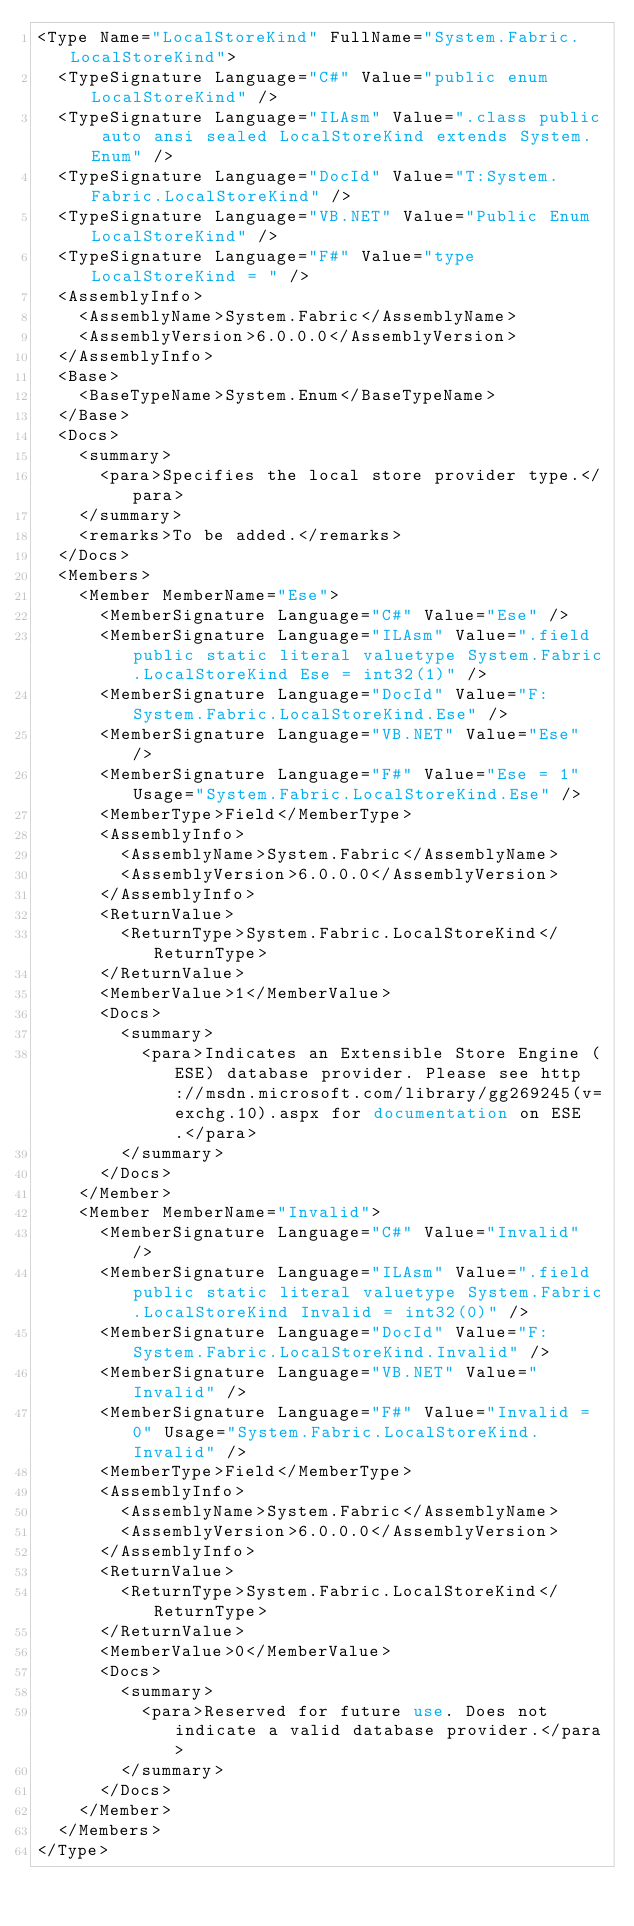Convert code to text. <code><loc_0><loc_0><loc_500><loc_500><_XML_><Type Name="LocalStoreKind" FullName="System.Fabric.LocalStoreKind">
  <TypeSignature Language="C#" Value="public enum LocalStoreKind" />
  <TypeSignature Language="ILAsm" Value=".class public auto ansi sealed LocalStoreKind extends System.Enum" />
  <TypeSignature Language="DocId" Value="T:System.Fabric.LocalStoreKind" />
  <TypeSignature Language="VB.NET" Value="Public Enum LocalStoreKind" />
  <TypeSignature Language="F#" Value="type LocalStoreKind = " />
  <AssemblyInfo>
    <AssemblyName>System.Fabric</AssemblyName>
    <AssemblyVersion>6.0.0.0</AssemblyVersion>
  </AssemblyInfo>
  <Base>
    <BaseTypeName>System.Enum</BaseTypeName>
  </Base>
  <Docs>
    <summary>
      <para>Specifies the local store provider type.</para>
    </summary>
    <remarks>To be added.</remarks>
  </Docs>
  <Members>
    <Member MemberName="Ese">
      <MemberSignature Language="C#" Value="Ese" />
      <MemberSignature Language="ILAsm" Value=".field public static literal valuetype System.Fabric.LocalStoreKind Ese = int32(1)" />
      <MemberSignature Language="DocId" Value="F:System.Fabric.LocalStoreKind.Ese" />
      <MemberSignature Language="VB.NET" Value="Ese" />
      <MemberSignature Language="F#" Value="Ese = 1" Usage="System.Fabric.LocalStoreKind.Ese" />
      <MemberType>Field</MemberType>
      <AssemblyInfo>
        <AssemblyName>System.Fabric</AssemblyName>
        <AssemblyVersion>6.0.0.0</AssemblyVersion>
      </AssemblyInfo>
      <ReturnValue>
        <ReturnType>System.Fabric.LocalStoreKind</ReturnType>
      </ReturnValue>
      <MemberValue>1</MemberValue>
      <Docs>
        <summary>
          <para>Indicates an Extensible Store Engine (ESE) database provider. Please see http://msdn.microsoft.com/library/gg269245(v=exchg.10).aspx for documentation on ESE.</para>
        </summary>
      </Docs>
    </Member>
    <Member MemberName="Invalid">
      <MemberSignature Language="C#" Value="Invalid" />
      <MemberSignature Language="ILAsm" Value=".field public static literal valuetype System.Fabric.LocalStoreKind Invalid = int32(0)" />
      <MemberSignature Language="DocId" Value="F:System.Fabric.LocalStoreKind.Invalid" />
      <MemberSignature Language="VB.NET" Value="Invalid" />
      <MemberSignature Language="F#" Value="Invalid = 0" Usage="System.Fabric.LocalStoreKind.Invalid" />
      <MemberType>Field</MemberType>
      <AssemblyInfo>
        <AssemblyName>System.Fabric</AssemblyName>
        <AssemblyVersion>6.0.0.0</AssemblyVersion>
      </AssemblyInfo>
      <ReturnValue>
        <ReturnType>System.Fabric.LocalStoreKind</ReturnType>
      </ReturnValue>
      <MemberValue>0</MemberValue>
      <Docs>
        <summary>
          <para>Reserved for future use. Does not indicate a valid database provider.</para>
        </summary>
      </Docs>
    </Member>
  </Members>
</Type>
</code> 